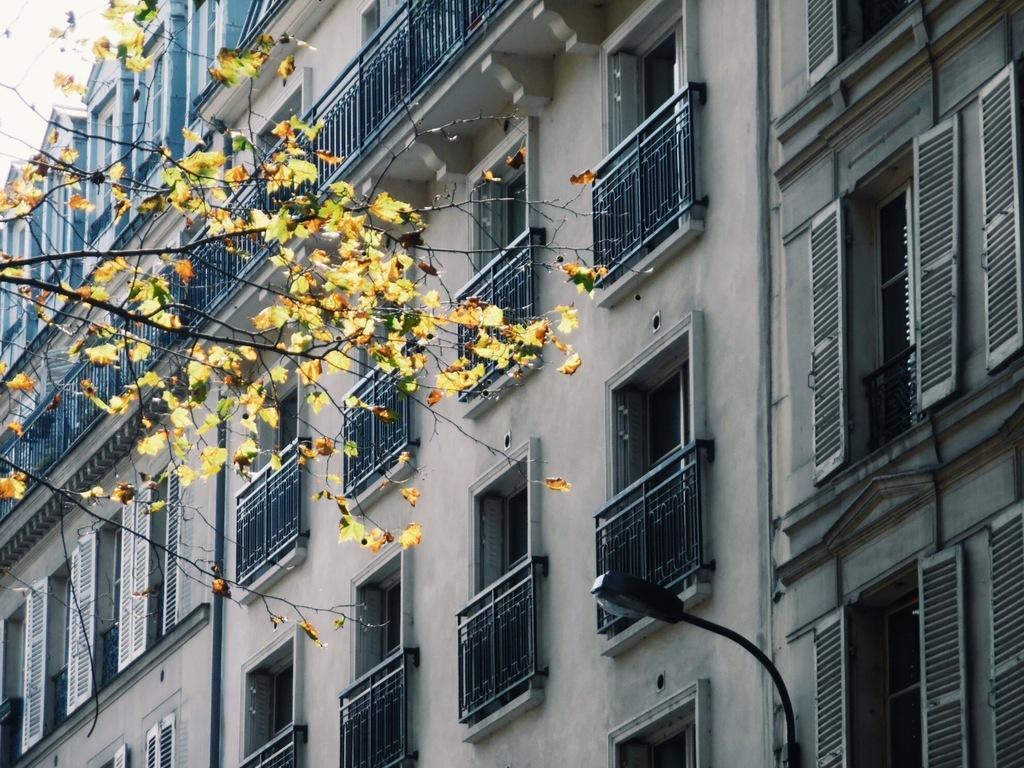Please provide a concise description of this image. In this picture I can see a tree and buildings. Here I can see a street light and windows. 